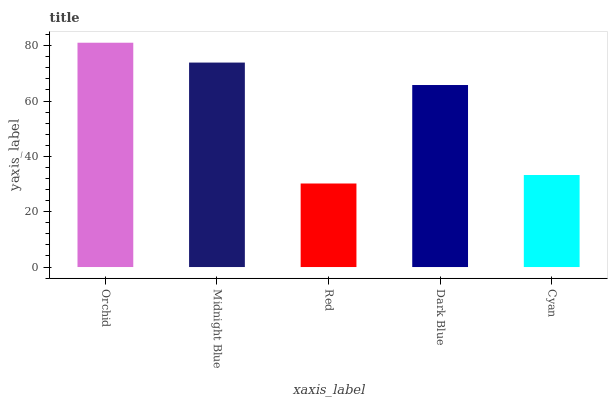Is Red the minimum?
Answer yes or no. Yes. Is Orchid the maximum?
Answer yes or no. Yes. Is Midnight Blue the minimum?
Answer yes or no. No. Is Midnight Blue the maximum?
Answer yes or no. No. Is Orchid greater than Midnight Blue?
Answer yes or no. Yes. Is Midnight Blue less than Orchid?
Answer yes or no. Yes. Is Midnight Blue greater than Orchid?
Answer yes or no. No. Is Orchid less than Midnight Blue?
Answer yes or no. No. Is Dark Blue the high median?
Answer yes or no. Yes. Is Dark Blue the low median?
Answer yes or no. Yes. Is Midnight Blue the high median?
Answer yes or no. No. Is Orchid the low median?
Answer yes or no. No. 